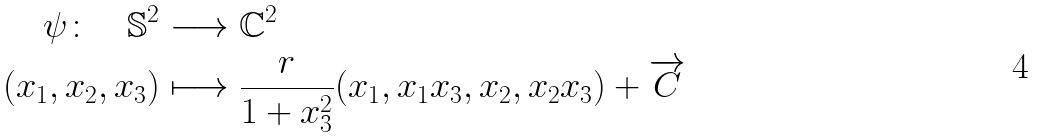<formula> <loc_0><loc_0><loc_500><loc_500>\psi \colon \quad \mathbb { S } ^ { 2 } & \longrightarrow \mathbb { C } ^ { 2 } \\ ( x _ { 1 } , x _ { 2 } , x _ { 3 } ) & \longmapsto \frac { r } { 1 + x ^ { 2 } _ { 3 } } ( x _ { 1 } , x _ { 1 } x _ { 3 } , x _ { 2 } , x _ { 2 } x _ { 3 } ) + \overrightarrow { C }</formula> 